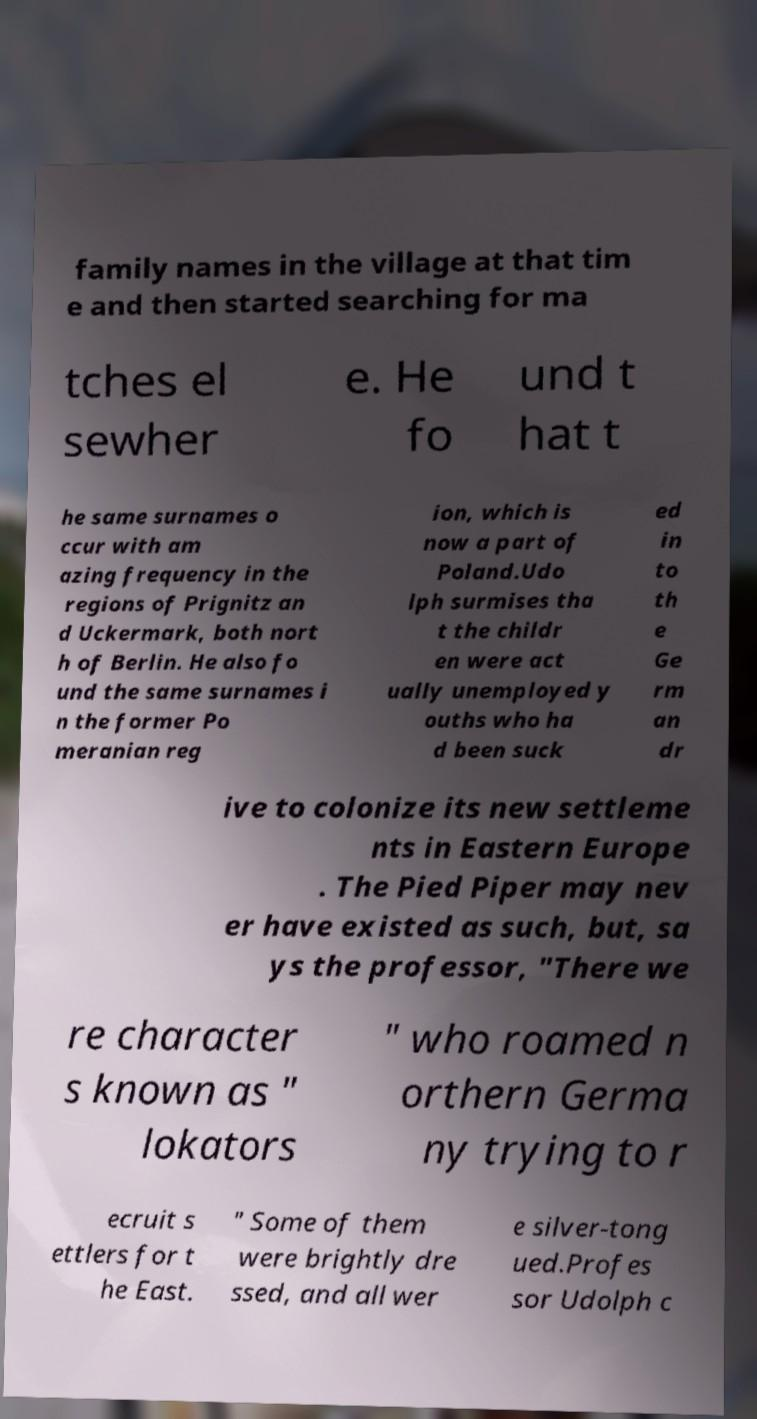Please identify and transcribe the text found in this image. family names in the village at that tim e and then started searching for ma tches el sewher e. He fo und t hat t he same surnames o ccur with am azing frequency in the regions of Prignitz an d Uckermark, both nort h of Berlin. He also fo und the same surnames i n the former Po meranian reg ion, which is now a part of Poland.Udo lph surmises tha t the childr en were act ually unemployed y ouths who ha d been suck ed in to th e Ge rm an dr ive to colonize its new settleme nts in Eastern Europe . The Pied Piper may nev er have existed as such, but, sa ys the professor, "There we re character s known as " lokators " who roamed n orthern Germa ny trying to r ecruit s ettlers for t he East. " Some of them were brightly dre ssed, and all wer e silver-tong ued.Profes sor Udolph c 